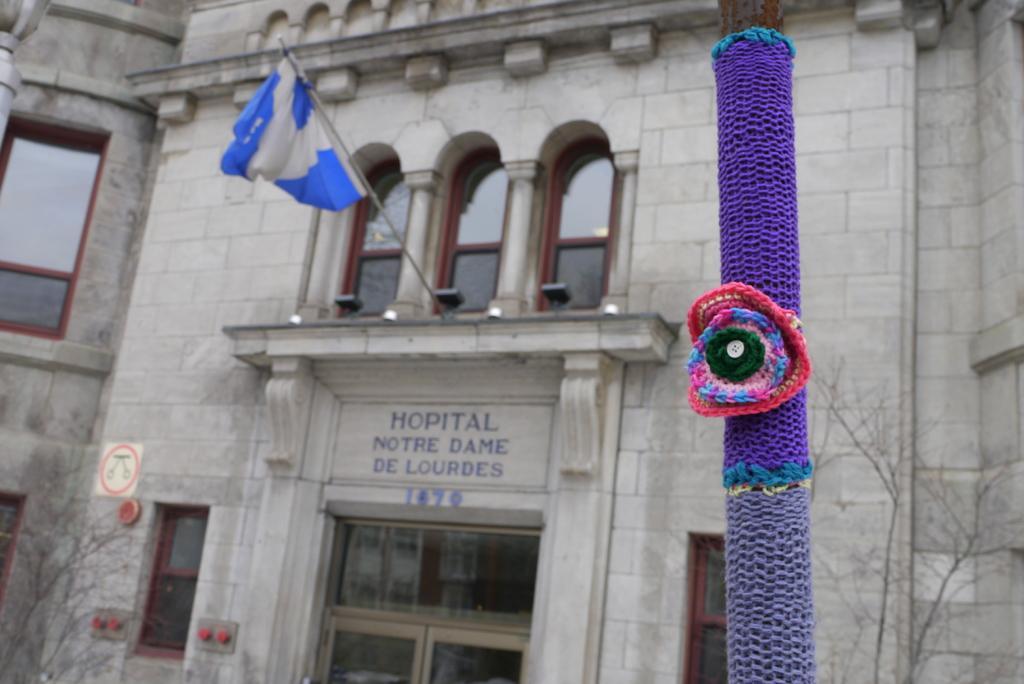How would you summarize this image in a sentence or two? In the middle of the image we can see a pole. Behind the pole there are some plants and building. On the building there are some windows, flag and sign board. 